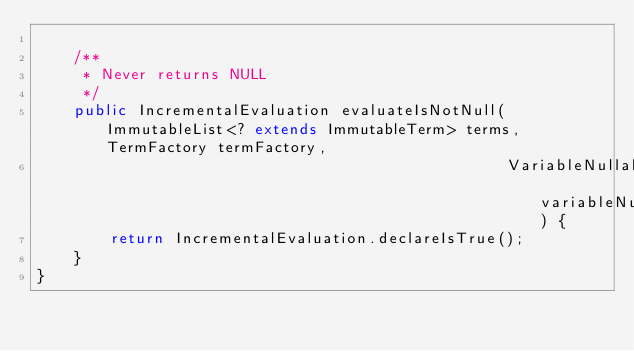<code> <loc_0><loc_0><loc_500><loc_500><_Java_>
    /**
     * Never returns NULL
     */
    public IncrementalEvaluation evaluateIsNotNull(ImmutableList<? extends ImmutableTerm> terms, TermFactory termFactory,
                                                   VariableNullability variableNullability) {
        return IncrementalEvaluation.declareIsTrue();
    }
}</code> 